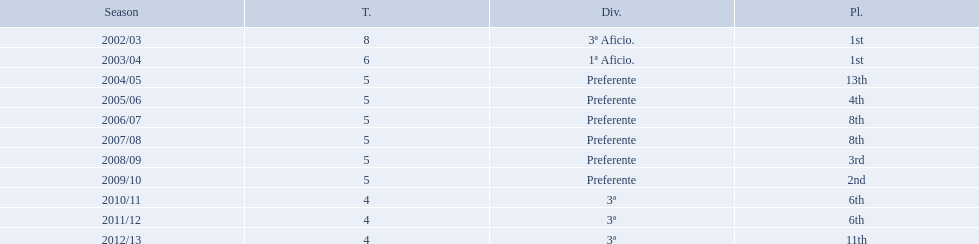Which seasons were played in tier four? 2010/11, 2011/12, 2012/13. Of these seasons, which resulted in 6th place? 2010/11, 2011/12. Which of the remaining happened last? 2011/12. What place did the team place in 2010/11? 6th. In what other year did they place 6th? 2011/12. 